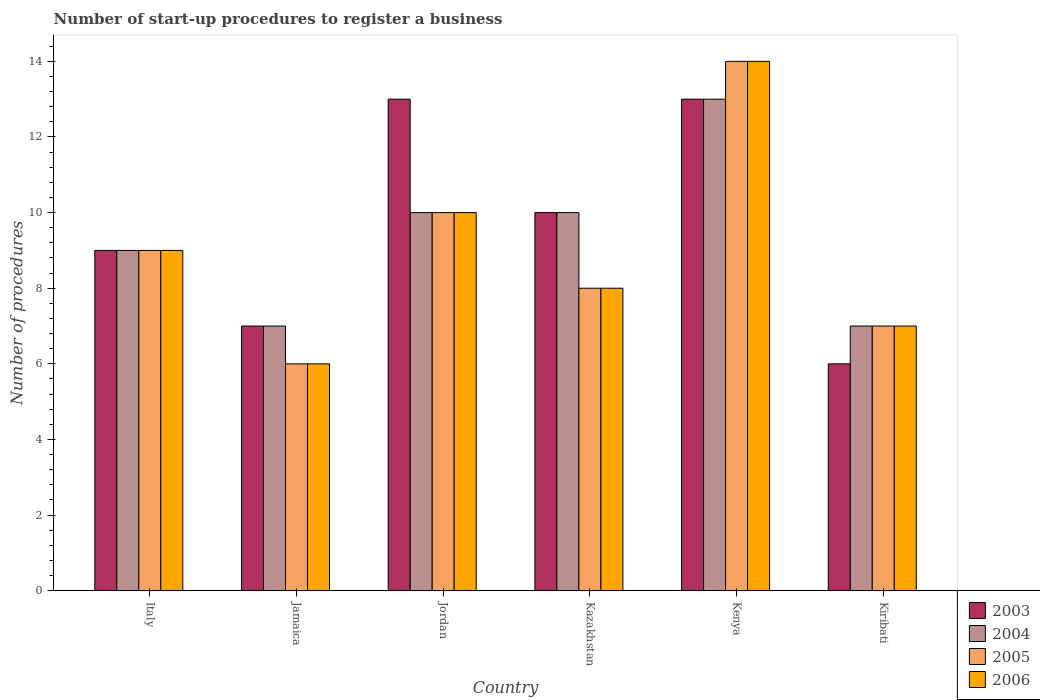How many different coloured bars are there?
Keep it short and to the point. 4. How many groups of bars are there?
Provide a succinct answer. 6. Are the number of bars on each tick of the X-axis equal?
Ensure brevity in your answer.  Yes. How many bars are there on the 5th tick from the right?
Provide a short and direct response. 4. What is the label of the 3rd group of bars from the left?
Your response must be concise. Jordan. In how many cases, is the number of bars for a given country not equal to the number of legend labels?
Your answer should be very brief. 0. What is the number of procedures required to register a business in 2004 in Jamaica?
Your answer should be very brief. 7. In which country was the number of procedures required to register a business in 2003 maximum?
Offer a terse response. Jordan. In which country was the number of procedures required to register a business in 2005 minimum?
Your response must be concise. Jamaica. What is the ratio of the number of procedures required to register a business in 2005 in Jordan to that in Kenya?
Offer a very short reply. 0.71. Is the difference between the number of procedures required to register a business in 2006 in Jordan and Kazakhstan greater than the difference between the number of procedures required to register a business in 2003 in Jordan and Kazakhstan?
Make the answer very short. No. Is the sum of the number of procedures required to register a business in 2005 in Italy and Kiribati greater than the maximum number of procedures required to register a business in 2006 across all countries?
Your answer should be compact. Yes. Is it the case that in every country, the sum of the number of procedures required to register a business in 2005 and number of procedures required to register a business in 2006 is greater than the sum of number of procedures required to register a business in 2004 and number of procedures required to register a business in 2003?
Your response must be concise. No. What does the 1st bar from the right in Kazakhstan represents?
Give a very brief answer. 2006. Is it the case that in every country, the sum of the number of procedures required to register a business in 2004 and number of procedures required to register a business in 2006 is greater than the number of procedures required to register a business in 2005?
Your answer should be very brief. Yes. How many countries are there in the graph?
Your response must be concise. 6. Are the values on the major ticks of Y-axis written in scientific E-notation?
Your answer should be compact. No. Does the graph contain any zero values?
Provide a succinct answer. No. Does the graph contain grids?
Provide a short and direct response. No. How are the legend labels stacked?
Keep it short and to the point. Vertical. What is the title of the graph?
Your answer should be very brief. Number of start-up procedures to register a business. What is the label or title of the X-axis?
Keep it short and to the point. Country. What is the label or title of the Y-axis?
Provide a short and direct response. Number of procedures. What is the Number of procedures of 2005 in Italy?
Your response must be concise. 9. What is the Number of procedures in 2003 in Jamaica?
Provide a short and direct response. 7. What is the Number of procedures in 2006 in Jamaica?
Give a very brief answer. 6. What is the Number of procedures in 2003 in Jordan?
Provide a short and direct response. 13. What is the Number of procedures of 2004 in Jordan?
Offer a very short reply. 10. What is the Number of procedures of 2006 in Jordan?
Your answer should be very brief. 10. What is the Number of procedures of 2003 in Kazakhstan?
Keep it short and to the point. 10. What is the Number of procedures of 2005 in Kazakhstan?
Provide a succinct answer. 8. What is the Number of procedures of 2006 in Kazakhstan?
Provide a short and direct response. 8. What is the Number of procedures of 2003 in Kenya?
Offer a very short reply. 13. What is the Number of procedures of 2004 in Kenya?
Your answer should be very brief. 13. What is the Number of procedures of 2006 in Kenya?
Provide a short and direct response. 14. What is the Number of procedures of 2005 in Kiribati?
Your answer should be compact. 7. Across all countries, what is the minimum Number of procedures in 2003?
Make the answer very short. 6. What is the total Number of procedures of 2003 in the graph?
Your answer should be compact. 58. What is the total Number of procedures of 2004 in the graph?
Your answer should be compact. 56. What is the difference between the Number of procedures of 2003 in Italy and that in Jamaica?
Provide a short and direct response. 2. What is the difference between the Number of procedures of 2005 in Italy and that in Jamaica?
Make the answer very short. 3. What is the difference between the Number of procedures of 2003 in Italy and that in Jordan?
Ensure brevity in your answer.  -4. What is the difference between the Number of procedures in 2004 in Italy and that in Jordan?
Make the answer very short. -1. What is the difference between the Number of procedures in 2005 in Italy and that in Kazakhstan?
Ensure brevity in your answer.  1. What is the difference between the Number of procedures in 2006 in Italy and that in Kazakhstan?
Offer a terse response. 1. What is the difference between the Number of procedures of 2004 in Italy and that in Kenya?
Keep it short and to the point. -4. What is the difference between the Number of procedures of 2005 in Italy and that in Kenya?
Give a very brief answer. -5. What is the difference between the Number of procedures in 2006 in Italy and that in Kenya?
Provide a short and direct response. -5. What is the difference between the Number of procedures of 2005 in Italy and that in Kiribati?
Make the answer very short. 2. What is the difference between the Number of procedures of 2003 in Jamaica and that in Jordan?
Give a very brief answer. -6. What is the difference between the Number of procedures in 2004 in Jamaica and that in Kazakhstan?
Keep it short and to the point. -3. What is the difference between the Number of procedures in 2005 in Jamaica and that in Kazakhstan?
Offer a terse response. -2. What is the difference between the Number of procedures of 2006 in Jamaica and that in Kazakhstan?
Your answer should be very brief. -2. What is the difference between the Number of procedures of 2003 in Jamaica and that in Kenya?
Give a very brief answer. -6. What is the difference between the Number of procedures of 2005 in Jamaica and that in Kenya?
Give a very brief answer. -8. What is the difference between the Number of procedures in 2003 in Jamaica and that in Kiribati?
Keep it short and to the point. 1. What is the difference between the Number of procedures of 2004 in Jamaica and that in Kiribati?
Your answer should be very brief. 0. What is the difference between the Number of procedures of 2005 in Jamaica and that in Kiribati?
Your response must be concise. -1. What is the difference between the Number of procedures in 2003 in Jordan and that in Kazakhstan?
Offer a very short reply. 3. What is the difference between the Number of procedures in 2004 in Jordan and that in Kiribati?
Provide a short and direct response. 3. What is the difference between the Number of procedures of 2003 in Kazakhstan and that in Kenya?
Ensure brevity in your answer.  -3. What is the difference between the Number of procedures of 2004 in Kazakhstan and that in Kiribati?
Make the answer very short. 3. What is the difference between the Number of procedures in 2005 in Kazakhstan and that in Kiribati?
Provide a short and direct response. 1. What is the difference between the Number of procedures in 2006 in Kazakhstan and that in Kiribati?
Offer a very short reply. 1. What is the difference between the Number of procedures of 2004 in Kenya and that in Kiribati?
Offer a terse response. 6. What is the difference between the Number of procedures in 2003 in Italy and the Number of procedures in 2004 in Jamaica?
Provide a short and direct response. 2. What is the difference between the Number of procedures in 2003 in Italy and the Number of procedures in 2005 in Jordan?
Your response must be concise. -1. What is the difference between the Number of procedures in 2003 in Italy and the Number of procedures in 2006 in Jordan?
Provide a succinct answer. -1. What is the difference between the Number of procedures in 2004 in Italy and the Number of procedures in 2005 in Jordan?
Keep it short and to the point. -1. What is the difference between the Number of procedures in 2004 in Italy and the Number of procedures in 2006 in Jordan?
Ensure brevity in your answer.  -1. What is the difference between the Number of procedures in 2003 in Italy and the Number of procedures in 2004 in Kazakhstan?
Give a very brief answer. -1. What is the difference between the Number of procedures in 2003 in Italy and the Number of procedures in 2005 in Kazakhstan?
Provide a succinct answer. 1. What is the difference between the Number of procedures in 2004 in Italy and the Number of procedures in 2005 in Kazakhstan?
Make the answer very short. 1. What is the difference between the Number of procedures in 2004 in Italy and the Number of procedures in 2006 in Kazakhstan?
Your answer should be compact. 1. What is the difference between the Number of procedures in 2005 in Italy and the Number of procedures in 2006 in Kazakhstan?
Provide a short and direct response. 1. What is the difference between the Number of procedures in 2003 in Italy and the Number of procedures in 2005 in Kenya?
Your answer should be compact. -5. What is the difference between the Number of procedures in 2004 in Italy and the Number of procedures in 2005 in Kenya?
Provide a succinct answer. -5. What is the difference between the Number of procedures of 2004 in Italy and the Number of procedures of 2006 in Kenya?
Your answer should be very brief. -5. What is the difference between the Number of procedures in 2003 in Italy and the Number of procedures in 2004 in Kiribati?
Offer a terse response. 2. What is the difference between the Number of procedures in 2003 in Italy and the Number of procedures in 2005 in Kiribati?
Offer a very short reply. 2. What is the difference between the Number of procedures of 2003 in Italy and the Number of procedures of 2006 in Kiribati?
Provide a succinct answer. 2. What is the difference between the Number of procedures of 2004 in Italy and the Number of procedures of 2006 in Kiribati?
Your answer should be very brief. 2. What is the difference between the Number of procedures of 2003 in Jamaica and the Number of procedures of 2004 in Jordan?
Ensure brevity in your answer.  -3. What is the difference between the Number of procedures in 2003 in Jamaica and the Number of procedures in 2004 in Kazakhstan?
Offer a terse response. -3. What is the difference between the Number of procedures of 2004 in Jamaica and the Number of procedures of 2005 in Kazakhstan?
Offer a very short reply. -1. What is the difference between the Number of procedures of 2004 in Jamaica and the Number of procedures of 2006 in Kazakhstan?
Your answer should be compact. -1. What is the difference between the Number of procedures of 2005 in Jamaica and the Number of procedures of 2006 in Kazakhstan?
Provide a short and direct response. -2. What is the difference between the Number of procedures of 2003 in Jamaica and the Number of procedures of 2004 in Kenya?
Make the answer very short. -6. What is the difference between the Number of procedures in 2003 in Jamaica and the Number of procedures in 2005 in Kenya?
Provide a succinct answer. -7. What is the difference between the Number of procedures in 2004 in Jamaica and the Number of procedures in 2005 in Kenya?
Provide a short and direct response. -7. What is the difference between the Number of procedures of 2004 in Jamaica and the Number of procedures of 2006 in Kenya?
Your answer should be compact. -7. What is the difference between the Number of procedures of 2003 in Jamaica and the Number of procedures of 2004 in Kiribati?
Provide a short and direct response. 0. What is the difference between the Number of procedures of 2003 in Jamaica and the Number of procedures of 2005 in Kiribati?
Your answer should be very brief. 0. What is the difference between the Number of procedures of 2003 in Jamaica and the Number of procedures of 2006 in Kiribati?
Provide a succinct answer. 0. What is the difference between the Number of procedures of 2004 in Jamaica and the Number of procedures of 2006 in Kiribati?
Your answer should be very brief. 0. What is the difference between the Number of procedures in 2005 in Jamaica and the Number of procedures in 2006 in Kiribati?
Keep it short and to the point. -1. What is the difference between the Number of procedures of 2003 in Jordan and the Number of procedures of 2004 in Kazakhstan?
Give a very brief answer. 3. What is the difference between the Number of procedures in 2003 in Jordan and the Number of procedures in 2006 in Kazakhstan?
Your answer should be compact. 5. What is the difference between the Number of procedures in 2005 in Jordan and the Number of procedures in 2006 in Kazakhstan?
Provide a short and direct response. 2. What is the difference between the Number of procedures in 2003 in Jordan and the Number of procedures in 2005 in Kenya?
Keep it short and to the point. -1. What is the difference between the Number of procedures in 2004 in Jordan and the Number of procedures in 2006 in Kenya?
Your response must be concise. -4. What is the difference between the Number of procedures of 2003 in Jordan and the Number of procedures of 2005 in Kiribati?
Ensure brevity in your answer.  6. What is the difference between the Number of procedures of 2004 in Jordan and the Number of procedures of 2005 in Kiribati?
Offer a very short reply. 3. What is the difference between the Number of procedures of 2004 in Jordan and the Number of procedures of 2006 in Kiribati?
Your answer should be very brief. 3. What is the difference between the Number of procedures in 2005 in Jordan and the Number of procedures in 2006 in Kiribati?
Provide a succinct answer. 3. What is the difference between the Number of procedures in 2003 in Kazakhstan and the Number of procedures in 2004 in Kenya?
Your response must be concise. -3. What is the difference between the Number of procedures in 2004 in Kazakhstan and the Number of procedures in 2005 in Kenya?
Your answer should be compact. -4. What is the difference between the Number of procedures in 2004 in Kazakhstan and the Number of procedures in 2006 in Kenya?
Provide a succinct answer. -4. What is the difference between the Number of procedures in 2005 in Kazakhstan and the Number of procedures in 2006 in Kenya?
Offer a terse response. -6. What is the difference between the Number of procedures in 2003 in Kazakhstan and the Number of procedures in 2005 in Kiribati?
Provide a short and direct response. 3. What is the difference between the Number of procedures of 2004 in Kazakhstan and the Number of procedures of 2005 in Kiribati?
Keep it short and to the point. 3. What is the difference between the Number of procedures in 2004 in Kazakhstan and the Number of procedures in 2006 in Kiribati?
Your response must be concise. 3. What is the difference between the Number of procedures in 2005 in Kazakhstan and the Number of procedures in 2006 in Kiribati?
Keep it short and to the point. 1. What is the difference between the Number of procedures of 2004 in Kenya and the Number of procedures of 2005 in Kiribati?
Keep it short and to the point. 6. What is the difference between the Number of procedures in 2004 in Kenya and the Number of procedures in 2006 in Kiribati?
Your answer should be compact. 6. What is the average Number of procedures of 2003 per country?
Give a very brief answer. 9.67. What is the average Number of procedures in 2004 per country?
Offer a very short reply. 9.33. What is the difference between the Number of procedures of 2003 and Number of procedures of 2005 in Italy?
Offer a terse response. 0. What is the difference between the Number of procedures of 2003 and Number of procedures of 2006 in Italy?
Your response must be concise. 0. What is the difference between the Number of procedures in 2004 and Number of procedures in 2005 in Italy?
Offer a terse response. 0. What is the difference between the Number of procedures of 2003 and Number of procedures of 2004 in Jamaica?
Provide a succinct answer. 0. What is the difference between the Number of procedures in 2003 and Number of procedures in 2006 in Jamaica?
Provide a succinct answer. 1. What is the difference between the Number of procedures in 2004 and Number of procedures in 2006 in Jamaica?
Your answer should be compact. 1. What is the difference between the Number of procedures in 2003 and Number of procedures in 2006 in Jordan?
Offer a very short reply. 3. What is the difference between the Number of procedures of 2004 and Number of procedures of 2006 in Jordan?
Keep it short and to the point. 0. What is the difference between the Number of procedures of 2005 and Number of procedures of 2006 in Jordan?
Offer a very short reply. 0. What is the difference between the Number of procedures of 2003 and Number of procedures of 2004 in Kazakhstan?
Make the answer very short. 0. What is the difference between the Number of procedures of 2003 and Number of procedures of 2006 in Kazakhstan?
Your answer should be very brief. 2. What is the difference between the Number of procedures in 2004 and Number of procedures in 2005 in Kazakhstan?
Make the answer very short. 2. What is the difference between the Number of procedures of 2005 and Number of procedures of 2006 in Kazakhstan?
Your answer should be very brief. 0. What is the difference between the Number of procedures in 2005 and Number of procedures in 2006 in Kenya?
Ensure brevity in your answer.  0. What is the difference between the Number of procedures of 2003 and Number of procedures of 2005 in Kiribati?
Keep it short and to the point. -1. What is the difference between the Number of procedures of 2004 and Number of procedures of 2005 in Kiribati?
Provide a succinct answer. 0. What is the difference between the Number of procedures in 2005 and Number of procedures in 2006 in Kiribati?
Your response must be concise. 0. What is the ratio of the Number of procedures of 2003 in Italy to that in Jamaica?
Offer a very short reply. 1.29. What is the ratio of the Number of procedures in 2004 in Italy to that in Jamaica?
Offer a terse response. 1.29. What is the ratio of the Number of procedures of 2005 in Italy to that in Jamaica?
Provide a succinct answer. 1.5. What is the ratio of the Number of procedures of 2003 in Italy to that in Jordan?
Provide a short and direct response. 0.69. What is the ratio of the Number of procedures of 2004 in Italy to that in Jordan?
Provide a short and direct response. 0.9. What is the ratio of the Number of procedures of 2006 in Italy to that in Jordan?
Offer a very short reply. 0.9. What is the ratio of the Number of procedures in 2003 in Italy to that in Kazakhstan?
Your response must be concise. 0.9. What is the ratio of the Number of procedures in 2004 in Italy to that in Kazakhstan?
Give a very brief answer. 0.9. What is the ratio of the Number of procedures in 2006 in Italy to that in Kazakhstan?
Provide a short and direct response. 1.12. What is the ratio of the Number of procedures in 2003 in Italy to that in Kenya?
Provide a short and direct response. 0.69. What is the ratio of the Number of procedures in 2004 in Italy to that in Kenya?
Provide a short and direct response. 0.69. What is the ratio of the Number of procedures of 2005 in Italy to that in Kenya?
Provide a succinct answer. 0.64. What is the ratio of the Number of procedures in 2006 in Italy to that in Kenya?
Provide a succinct answer. 0.64. What is the ratio of the Number of procedures in 2004 in Italy to that in Kiribati?
Your answer should be compact. 1.29. What is the ratio of the Number of procedures in 2005 in Italy to that in Kiribati?
Your answer should be very brief. 1.29. What is the ratio of the Number of procedures in 2006 in Italy to that in Kiribati?
Your answer should be very brief. 1.29. What is the ratio of the Number of procedures of 2003 in Jamaica to that in Jordan?
Your answer should be very brief. 0.54. What is the ratio of the Number of procedures in 2004 in Jamaica to that in Jordan?
Provide a short and direct response. 0.7. What is the ratio of the Number of procedures of 2005 in Jamaica to that in Jordan?
Your answer should be very brief. 0.6. What is the ratio of the Number of procedures in 2006 in Jamaica to that in Jordan?
Ensure brevity in your answer.  0.6. What is the ratio of the Number of procedures of 2003 in Jamaica to that in Kazakhstan?
Provide a short and direct response. 0.7. What is the ratio of the Number of procedures in 2003 in Jamaica to that in Kenya?
Your answer should be very brief. 0.54. What is the ratio of the Number of procedures in 2004 in Jamaica to that in Kenya?
Provide a succinct answer. 0.54. What is the ratio of the Number of procedures in 2005 in Jamaica to that in Kenya?
Your answer should be very brief. 0.43. What is the ratio of the Number of procedures in 2006 in Jamaica to that in Kenya?
Give a very brief answer. 0.43. What is the ratio of the Number of procedures of 2003 in Jamaica to that in Kiribati?
Provide a succinct answer. 1.17. What is the ratio of the Number of procedures in 2003 in Jordan to that in Kazakhstan?
Make the answer very short. 1.3. What is the ratio of the Number of procedures of 2004 in Jordan to that in Kazakhstan?
Ensure brevity in your answer.  1. What is the ratio of the Number of procedures of 2005 in Jordan to that in Kazakhstan?
Your answer should be compact. 1.25. What is the ratio of the Number of procedures of 2004 in Jordan to that in Kenya?
Your answer should be very brief. 0.77. What is the ratio of the Number of procedures of 2003 in Jordan to that in Kiribati?
Your answer should be compact. 2.17. What is the ratio of the Number of procedures in 2004 in Jordan to that in Kiribati?
Your response must be concise. 1.43. What is the ratio of the Number of procedures in 2005 in Jordan to that in Kiribati?
Provide a short and direct response. 1.43. What is the ratio of the Number of procedures of 2006 in Jordan to that in Kiribati?
Provide a short and direct response. 1.43. What is the ratio of the Number of procedures in 2003 in Kazakhstan to that in Kenya?
Provide a short and direct response. 0.77. What is the ratio of the Number of procedures of 2004 in Kazakhstan to that in Kenya?
Make the answer very short. 0.77. What is the ratio of the Number of procedures of 2003 in Kazakhstan to that in Kiribati?
Your response must be concise. 1.67. What is the ratio of the Number of procedures of 2004 in Kazakhstan to that in Kiribati?
Your response must be concise. 1.43. What is the ratio of the Number of procedures of 2005 in Kazakhstan to that in Kiribati?
Make the answer very short. 1.14. What is the ratio of the Number of procedures of 2006 in Kazakhstan to that in Kiribati?
Provide a succinct answer. 1.14. What is the ratio of the Number of procedures in 2003 in Kenya to that in Kiribati?
Offer a very short reply. 2.17. What is the ratio of the Number of procedures of 2004 in Kenya to that in Kiribati?
Your answer should be very brief. 1.86. What is the ratio of the Number of procedures in 2005 in Kenya to that in Kiribati?
Offer a very short reply. 2. What is the difference between the highest and the second highest Number of procedures of 2006?
Offer a terse response. 4. What is the difference between the highest and the lowest Number of procedures in 2004?
Your response must be concise. 6. What is the difference between the highest and the lowest Number of procedures in 2005?
Make the answer very short. 8. What is the difference between the highest and the lowest Number of procedures in 2006?
Offer a terse response. 8. 